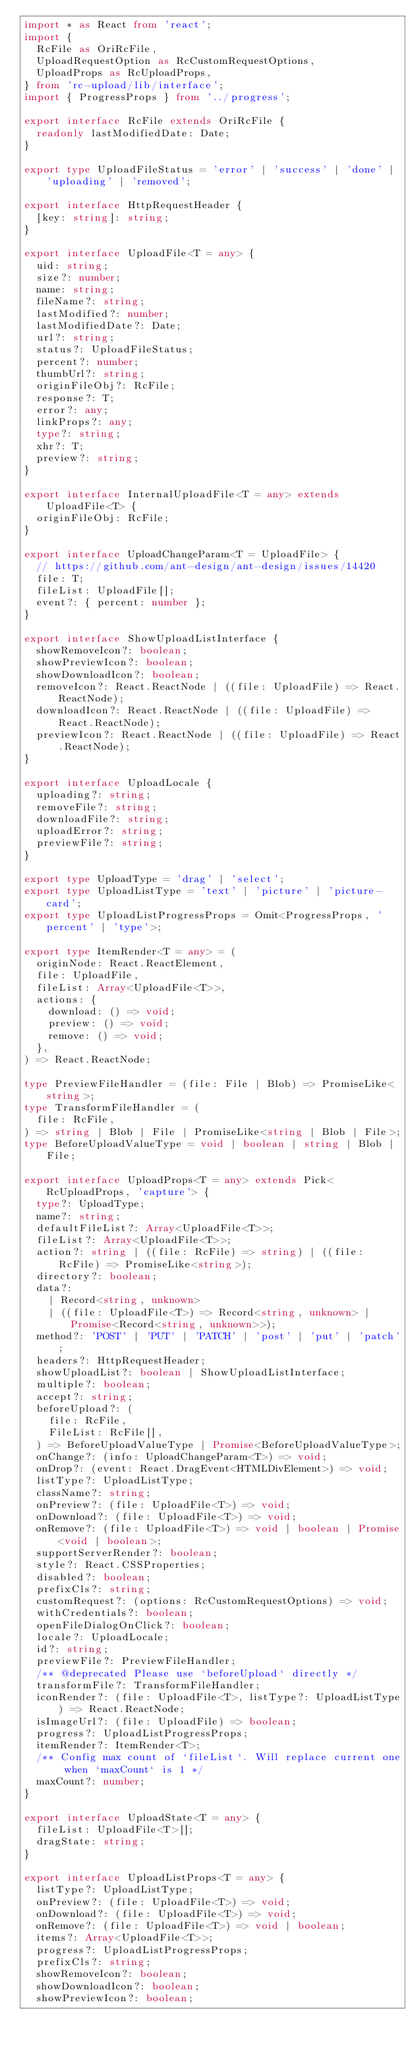Convert code to text. <code><loc_0><loc_0><loc_500><loc_500><_TypeScript_>import * as React from 'react';
import {
  RcFile as OriRcFile,
  UploadRequestOption as RcCustomRequestOptions,
  UploadProps as RcUploadProps,
} from 'rc-upload/lib/interface';
import { ProgressProps } from '../progress';

export interface RcFile extends OriRcFile {
  readonly lastModifiedDate: Date;
}

export type UploadFileStatus = 'error' | 'success' | 'done' | 'uploading' | 'removed';

export interface HttpRequestHeader {
  [key: string]: string;
}

export interface UploadFile<T = any> {
  uid: string;
  size?: number;
  name: string;
  fileName?: string;
  lastModified?: number;
  lastModifiedDate?: Date;
  url?: string;
  status?: UploadFileStatus;
  percent?: number;
  thumbUrl?: string;
  originFileObj?: RcFile;
  response?: T;
  error?: any;
  linkProps?: any;
  type?: string;
  xhr?: T;
  preview?: string;
}

export interface InternalUploadFile<T = any> extends UploadFile<T> {
  originFileObj: RcFile;
}

export interface UploadChangeParam<T = UploadFile> {
  // https://github.com/ant-design/ant-design/issues/14420
  file: T;
  fileList: UploadFile[];
  event?: { percent: number };
}

export interface ShowUploadListInterface {
  showRemoveIcon?: boolean;
  showPreviewIcon?: boolean;
  showDownloadIcon?: boolean;
  removeIcon?: React.ReactNode | ((file: UploadFile) => React.ReactNode);
  downloadIcon?: React.ReactNode | ((file: UploadFile) => React.ReactNode);
  previewIcon?: React.ReactNode | ((file: UploadFile) => React.ReactNode);
}

export interface UploadLocale {
  uploading?: string;
  removeFile?: string;
  downloadFile?: string;
  uploadError?: string;
  previewFile?: string;
}

export type UploadType = 'drag' | 'select';
export type UploadListType = 'text' | 'picture' | 'picture-card';
export type UploadListProgressProps = Omit<ProgressProps, 'percent' | 'type'>;

export type ItemRender<T = any> = (
  originNode: React.ReactElement,
  file: UploadFile,
  fileList: Array<UploadFile<T>>,
  actions: {
    download: () => void;
    preview: () => void;
    remove: () => void;
  },
) => React.ReactNode;

type PreviewFileHandler = (file: File | Blob) => PromiseLike<string>;
type TransformFileHandler = (
  file: RcFile,
) => string | Blob | File | PromiseLike<string | Blob | File>;
type BeforeUploadValueType = void | boolean | string | Blob | File;

export interface UploadProps<T = any> extends Pick<RcUploadProps, 'capture'> {
  type?: UploadType;
  name?: string;
  defaultFileList?: Array<UploadFile<T>>;
  fileList?: Array<UploadFile<T>>;
  action?: string | ((file: RcFile) => string) | ((file: RcFile) => PromiseLike<string>);
  directory?: boolean;
  data?:
    | Record<string, unknown>
    | ((file: UploadFile<T>) => Record<string, unknown> | Promise<Record<string, unknown>>);
  method?: 'POST' | 'PUT' | 'PATCH' | 'post' | 'put' | 'patch';
  headers?: HttpRequestHeader;
  showUploadList?: boolean | ShowUploadListInterface;
  multiple?: boolean;
  accept?: string;
  beforeUpload?: (
    file: RcFile,
    FileList: RcFile[],
  ) => BeforeUploadValueType | Promise<BeforeUploadValueType>;
  onChange?: (info: UploadChangeParam<T>) => void;
  onDrop?: (event: React.DragEvent<HTMLDivElement>) => void;
  listType?: UploadListType;
  className?: string;
  onPreview?: (file: UploadFile<T>) => void;
  onDownload?: (file: UploadFile<T>) => void;
  onRemove?: (file: UploadFile<T>) => void | boolean | Promise<void | boolean>;
  supportServerRender?: boolean;
  style?: React.CSSProperties;
  disabled?: boolean;
  prefixCls?: string;
  customRequest?: (options: RcCustomRequestOptions) => void;
  withCredentials?: boolean;
  openFileDialogOnClick?: boolean;
  locale?: UploadLocale;
  id?: string;
  previewFile?: PreviewFileHandler;
  /** @deprecated Please use `beforeUpload` directly */
  transformFile?: TransformFileHandler;
  iconRender?: (file: UploadFile<T>, listType?: UploadListType) => React.ReactNode;
  isImageUrl?: (file: UploadFile) => boolean;
  progress?: UploadListProgressProps;
  itemRender?: ItemRender<T>;
  /** Config max count of `fileList`. Will replace current one when `maxCount` is 1 */
  maxCount?: number;
}

export interface UploadState<T = any> {
  fileList: UploadFile<T>[];
  dragState: string;
}

export interface UploadListProps<T = any> {
  listType?: UploadListType;
  onPreview?: (file: UploadFile<T>) => void;
  onDownload?: (file: UploadFile<T>) => void;
  onRemove?: (file: UploadFile<T>) => void | boolean;
  items?: Array<UploadFile<T>>;
  progress?: UploadListProgressProps;
  prefixCls?: string;
  showRemoveIcon?: boolean;
  showDownloadIcon?: boolean;
  showPreviewIcon?: boolean;</code> 